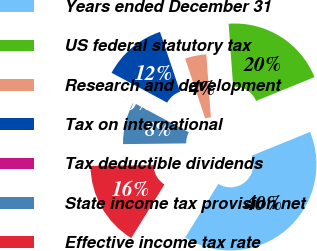Convert chart to OTSL. <chart><loc_0><loc_0><loc_500><loc_500><pie_chart><fcel>Years ended December 31<fcel>US federal statutory tax<fcel>Research and development<fcel>Tax on international<fcel>Tax deductible dividends<fcel>State income tax provision net<fcel>Effective income tax rate<nl><fcel>39.97%<fcel>19.99%<fcel>4.01%<fcel>12.0%<fcel>0.01%<fcel>8.01%<fcel>16.0%<nl></chart> 